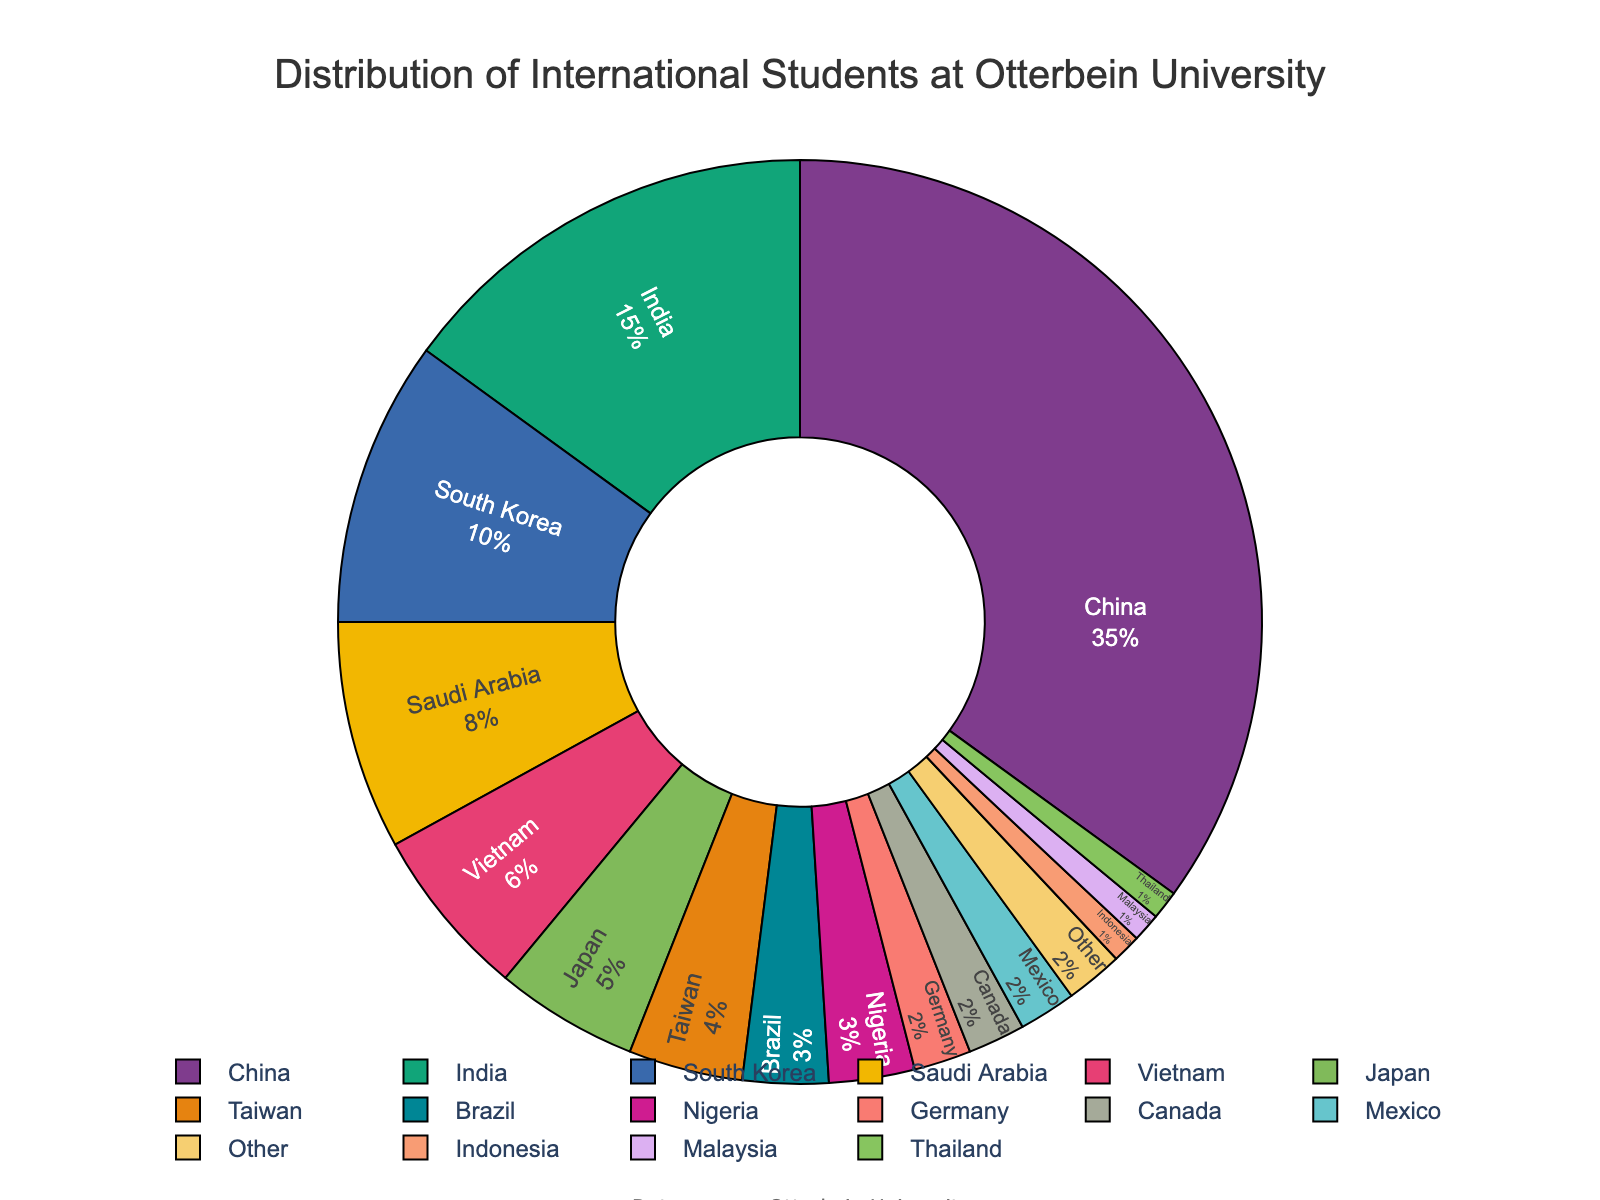What percentage of international students come from China? The figure shows a pie chart with the distribution of international students by country. The segment labeled "China" indicates the percentage of international students from China.
Answer: 35 Which countries have a lower percentage of international students compared to Taiwan? The pie chart shows Taiwan with a 4% share. By comparing the sizes and labels, the countries with a lower percentage than Taiwan are Brazil, Nigeria, Germany, Canada, Mexico, Indonesia, Malaysia, and Thailand.
Answer: Brazil, Nigeria, Germany, Canada, Mexico, Indonesia, Malaysia, Thailand What is the combined percentage of international students from India and South Korea? According to the pie chart, the percentage of international students from India is 15% and from South Korea is 10%. Adding these together gives 15 + 10 = 25%.
Answer: 25 How many countries have an equal percentage of international students, and what is the percentage? The pie chart shows that Germany, Canada, and Mexico each have 2% of the international students. Since all three have the same percentage, the answer is 3 countries with 2%.
Answer: 3 countries, 2% What is the total percentage of international students from Asian countries (China, India, South Korea, Saudi Arabia, Vietnam, Japan, Taiwan, Indonesia, Malaysia, Thailand)? Summing up the percentages: China (35) + India (15) + South Korea (10) + Saudi Arabia (8) + Vietnam (6) + Japan (5) + Taiwan (4) + Indonesia (1) + Malaysia (1) + Thailand (1) = 86%.
Answer: 86 Which country represents the smallest segment in the pie chart, and what is its percentage? The smallest segments in the pie chart are labeled as Indonesia, Malaysia, and Thailand, each with 1%.
Answer: Indonesia, Malaysia, Thailand, 1 How much larger is the percentage of international students from China compared to the percentage from Saudi Arabia? China has 35% while Saudi Arabia has 8%. The difference is 35 - 8 = 27%.
Answer: 27 What is the percentage difference between Japan and Vietnam? Japan’s percentage is 5% and Vietnam’s percentage is 6%. The difference between them is 6 - 5 = 1%.
Answer: 1 How many countries have a percentage of 5 or higher? Reviewing the pie chart, the countries with a percentage of 5 or higher are China (35), India (15), South Korea (10), Saudi Arabia (8), Vietnam (6), and Japan (5). There are 6 such countries.
Answer: 6 What percentage of international students come from countries other than China, India, and South Korea? The total percentage for China, India, and South Korea is 35 + 15 + 10 = 60%. Subtracting this from 100% gives 100 - 60 = 40%.
Answer: 40 